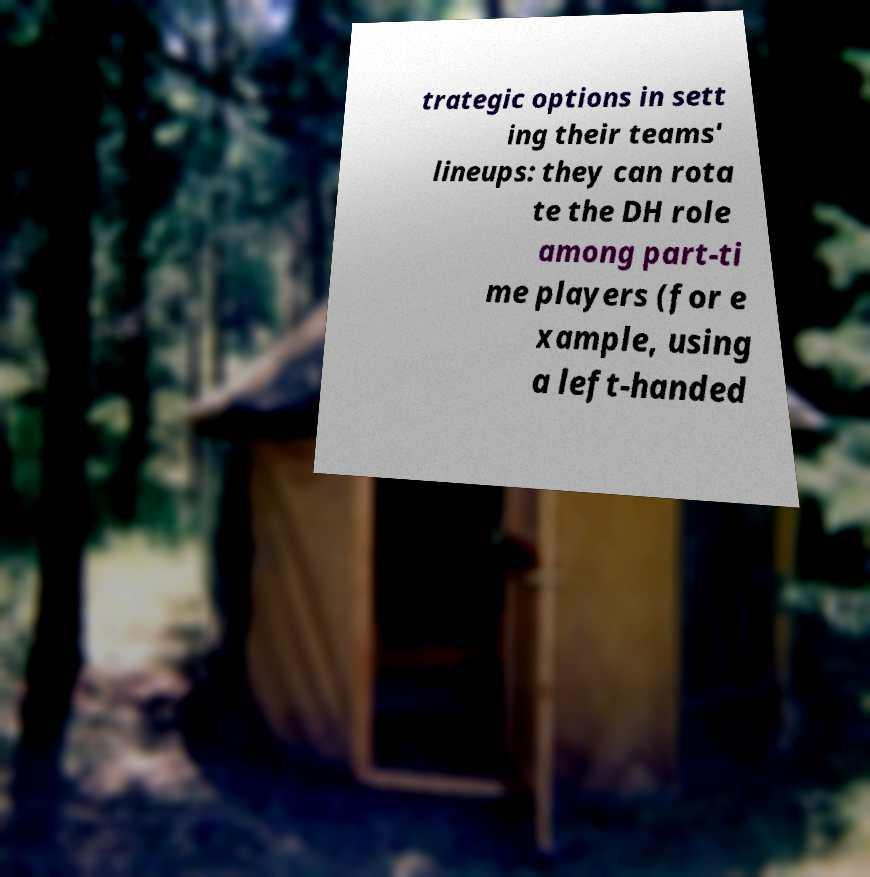For documentation purposes, I need the text within this image transcribed. Could you provide that? trategic options in sett ing their teams' lineups: they can rota te the DH role among part-ti me players (for e xample, using a left-handed 